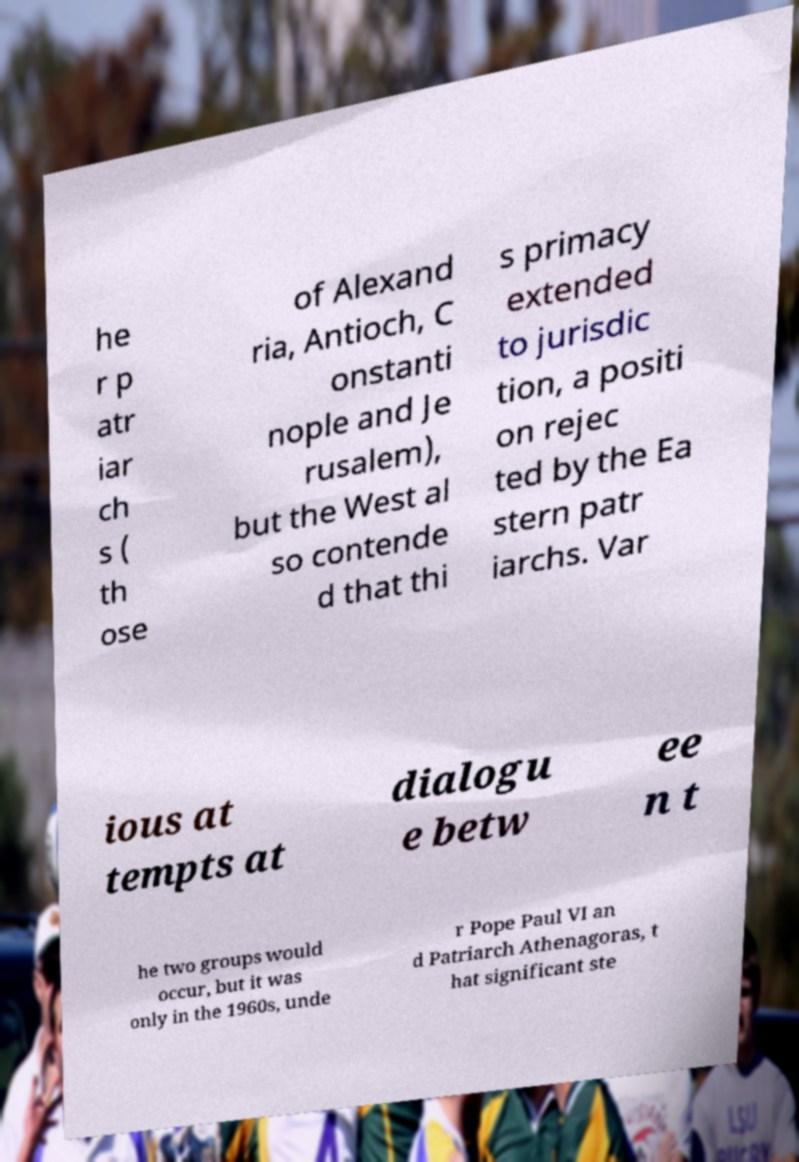There's text embedded in this image that I need extracted. Can you transcribe it verbatim? he r p atr iar ch s ( th ose of Alexand ria, Antioch, C onstanti nople and Je rusalem), but the West al so contende d that thi s primacy extended to jurisdic tion, a positi on rejec ted by the Ea stern patr iarchs. Var ious at tempts at dialogu e betw ee n t he two groups would occur, but it was only in the 1960s, unde r Pope Paul VI an d Patriarch Athenagoras, t hat significant ste 